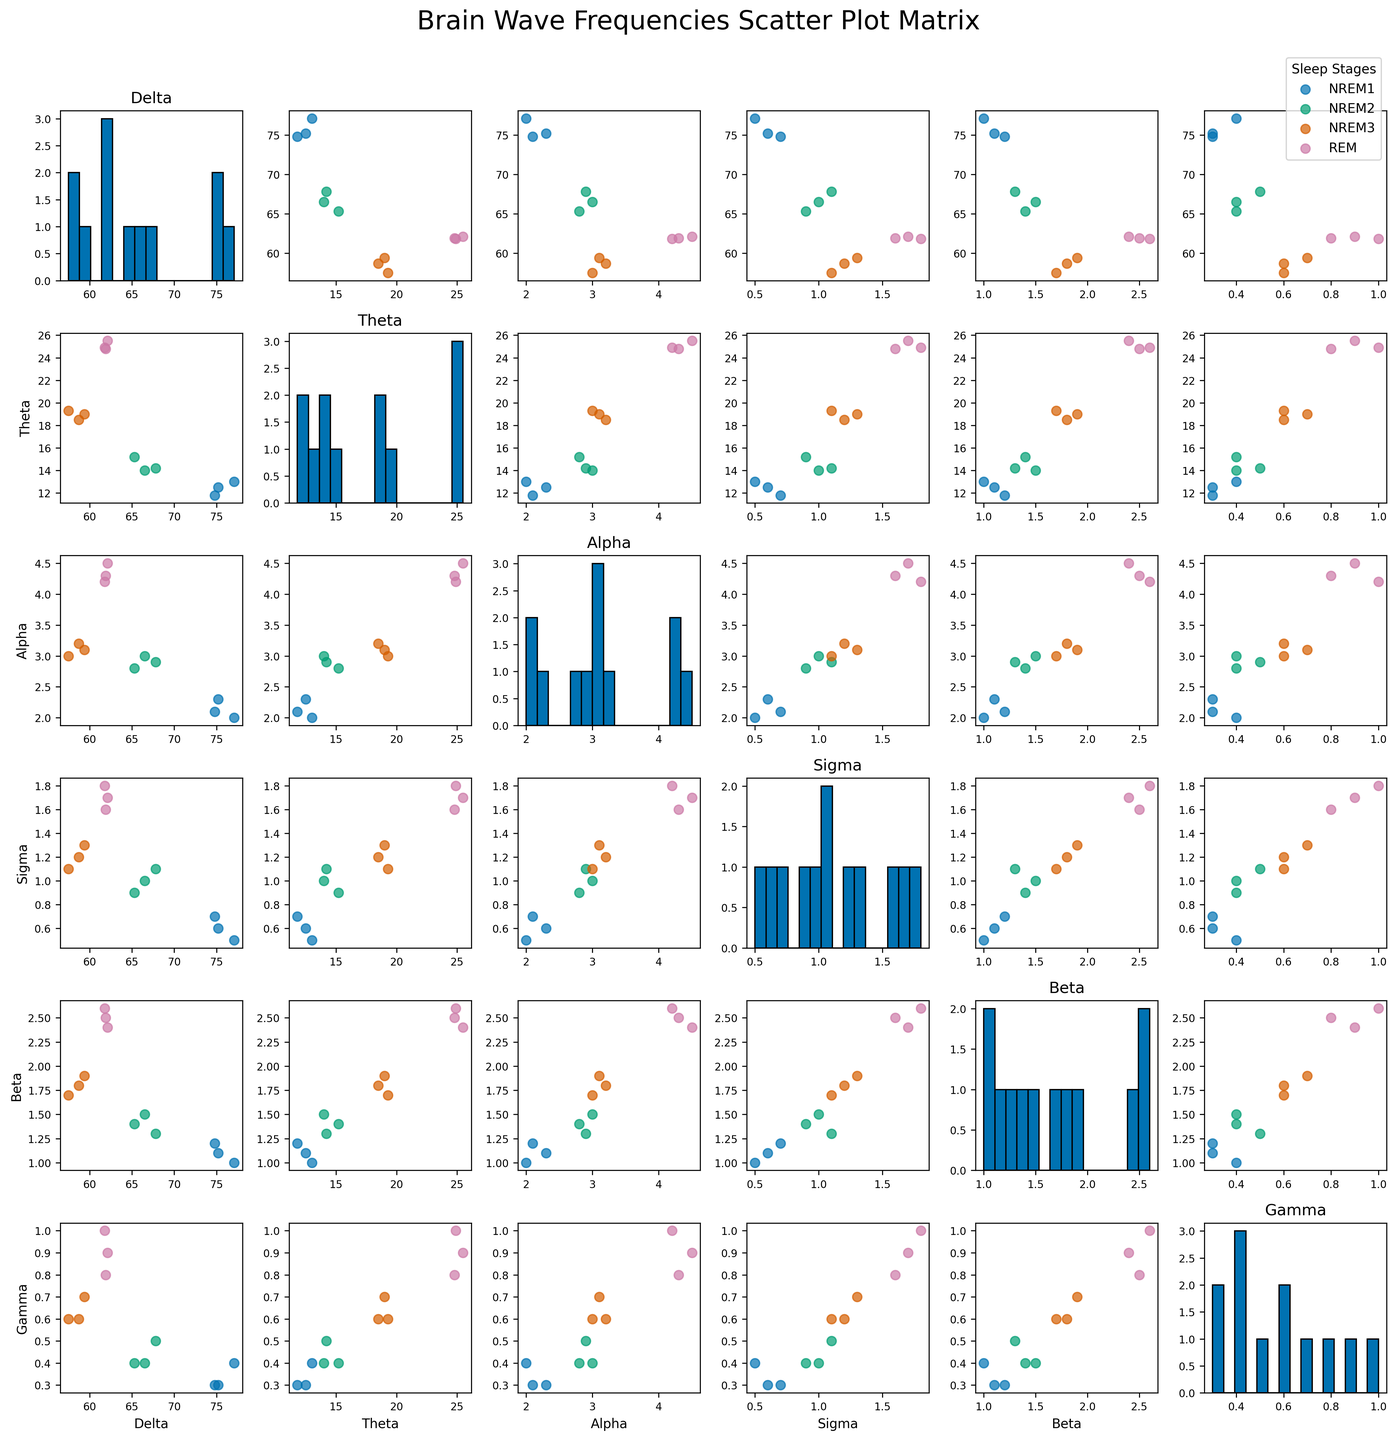What is the title of the scatter plot matrix? The title is located at the top of the figure, usually in larger font size and more prominent than other elements.
Answer: Brain Wave Frequencies Scatter Plot Matrix How are the sleep stages represented in the scatter plots? Different sleep stages are represented by different colors in the scatter plots. The legend in the upper right corner explains which color represents which sleep stage.
Answer: By different colors Which brain wave type typically has the highest frequency values in REM sleep? By checking the highest frequency values for different brain waves in the REM sleep scatter plots, one can identify the brain wave type. In this case, Theta waves show the highest values in REM sleep.
Answer: Theta Are Delta and Beta wave frequencies correlated in any of the sleep stages? To determine correlation, look for a consistent pattern or trend in the scatter plots between Delta and Beta wave frequencies for each sleep stage. There doesn't appear to be a strong correlation in any sleep stage.
Answer: Not strongly correlated Which brain wave frequency shows the most variation during NREM3 sleep? By observing the histograms along the diagonal for each brain wave type and comparing the spread of values during NREM3 sleep, Theta waves demonstrate the most variation during NREM3 sleep.
Answer: Theta How do Delta wave frequencies compare between NREM1 and NREM3 sleep stages? To compare Delta wave frequencies between NREM1 and NREM3, examine the scatter plots involving Delta waves for these stages. NREM3 shows lower Delta wave frequencies than NREM1.
Answer: Lower in NREM3 What's the trend of Alpha wave frequency from NREM1 to REM sleep? By examining the scatter plots for Alpha waves across different sleep stages, note the frequencies for Alpha waves. Alpha wave frequencies increase sequentially from NREM1, NREM2, NREM3, to REM sleep.
Answer: Increasing Which brain wave frequency shows the smallest differences across different sleep stages? Observing the histograms along the diagonal, Gamma waves show smaller variations compared to other brain waves across different sleep stages.
Answer: Gamma What is the average Delta wave frequency during NREM2 sleep? To calculate this, identify the Delta values for NREM2 sleep stages: 65.3, 66.5, and 67.8. Sum these values (65.3 + 66.5 + 67.8 = 199.6) and divide by the count (199.6 / 3).
Answer: 66.53 Do Sigma wave frequencies overlap significantly between any two sleep stages? Navigating through each plot in the Sigma wave column and row, check if the points for at least two sleep stages overlap significantly. The scatter points for NREM2 and NREM3 overlap somewhat.
Answer: NREM2 and NREM3 